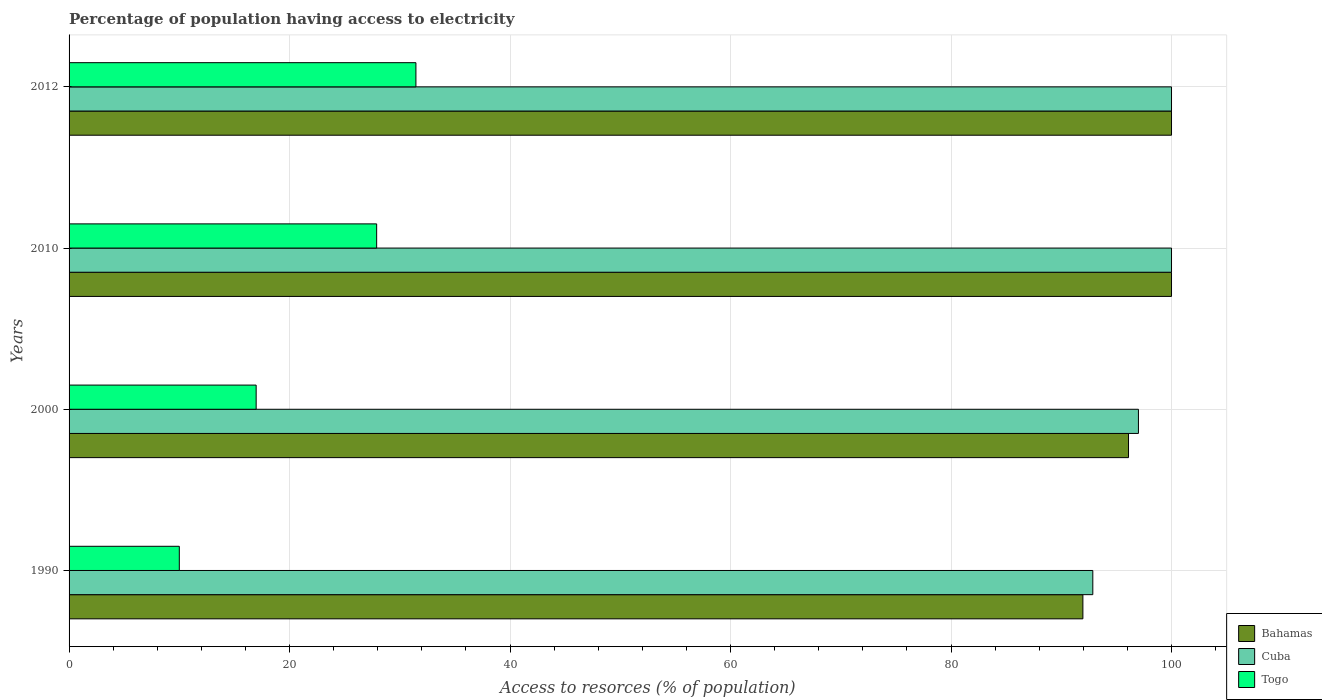How many different coloured bars are there?
Keep it short and to the point. 3. How many groups of bars are there?
Keep it short and to the point. 4. Are the number of bars per tick equal to the number of legend labels?
Your response must be concise. Yes. How many bars are there on the 2nd tick from the top?
Make the answer very short. 3. How many bars are there on the 2nd tick from the bottom?
Give a very brief answer. 3. In how many cases, is the number of bars for a given year not equal to the number of legend labels?
Provide a succinct answer. 0. What is the percentage of population having access to electricity in Bahamas in 2000?
Offer a terse response. 96.1. What is the total percentage of population having access to electricity in Cuba in the graph?
Provide a short and direct response. 389.86. What is the difference between the percentage of population having access to electricity in Bahamas in 1990 and the percentage of population having access to electricity in Togo in 2000?
Provide a succinct answer. 74.99. What is the average percentage of population having access to electricity in Togo per year?
Keep it short and to the point. 21.58. In the year 2010, what is the difference between the percentage of population having access to electricity in Togo and percentage of population having access to electricity in Bahamas?
Your answer should be very brief. -72.1. In how many years, is the percentage of population having access to electricity in Bahamas greater than 48 %?
Your answer should be very brief. 4. What is the ratio of the percentage of population having access to electricity in Bahamas in 1990 to that in 2010?
Provide a short and direct response. 0.92. Is the percentage of population having access to electricity in Bahamas in 2010 less than that in 2012?
Ensure brevity in your answer.  No. What is the difference between the highest and the lowest percentage of population having access to electricity in Cuba?
Offer a terse response. 7.14. Is the sum of the percentage of population having access to electricity in Togo in 2000 and 2012 greater than the maximum percentage of population having access to electricity in Cuba across all years?
Ensure brevity in your answer.  No. What does the 2nd bar from the top in 2010 represents?
Offer a very short reply. Cuba. What does the 2nd bar from the bottom in 2010 represents?
Offer a terse response. Cuba. Is it the case that in every year, the sum of the percentage of population having access to electricity in Togo and percentage of population having access to electricity in Cuba is greater than the percentage of population having access to electricity in Bahamas?
Ensure brevity in your answer.  Yes. What is the difference between two consecutive major ticks on the X-axis?
Your response must be concise. 20. Are the values on the major ticks of X-axis written in scientific E-notation?
Provide a succinct answer. No. Does the graph contain any zero values?
Offer a very short reply. No. Does the graph contain grids?
Offer a very short reply. Yes. Where does the legend appear in the graph?
Offer a terse response. Bottom right. How many legend labels are there?
Offer a very short reply. 3. What is the title of the graph?
Provide a short and direct response. Percentage of population having access to electricity. Does "Romania" appear as one of the legend labels in the graph?
Your response must be concise. No. What is the label or title of the X-axis?
Ensure brevity in your answer.  Access to resorces (% of population). What is the Access to resorces (% of population) in Bahamas in 1990?
Offer a very short reply. 91.96. What is the Access to resorces (% of population) of Cuba in 1990?
Offer a terse response. 92.86. What is the Access to resorces (% of population) in Bahamas in 2000?
Keep it short and to the point. 96.1. What is the Access to resorces (% of population) of Cuba in 2000?
Offer a terse response. 97. What is the Access to resorces (% of population) of Togo in 2000?
Offer a very short reply. 16.97. What is the Access to resorces (% of population) of Cuba in 2010?
Ensure brevity in your answer.  100. What is the Access to resorces (% of population) in Togo in 2010?
Offer a terse response. 27.9. What is the Access to resorces (% of population) of Bahamas in 2012?
Give a very brief answer. 100. What is the Access to resorces (% of population) of Togo in 2012?
Make the answer very short. 31.46. Across all years, what is the maximum Access to resorces (% of population) of Cuba?
Keep it short and to the point. 100. Across all years, what is the maximum Access to resorces (% of population) of Togo?
Make the answer very short. 31.46. Across all years, what is the minimum Access to resorces (% of population) of Bahamas?
Your answer should be very brief. 91.96. Across all years, what is the minimum Access to resorces (% of population) in Cuba?
Offer a terse response. 92.86. Across all years, what is the minimum Access to resorces (% of population) of Togo?
Make the answer very short. 10. What is the total Access to resorces (% of population) in Bahamas in the graph?
Your answer should be very brief. 388.06. What is the total Access to resorces (% of population) of Cuba in the graph?
Your answer should be very brief. 389.86. What is the total Access to resorces (% of population) in Togo in the graph?
Your answer should be compact. 86.33. What is the difference between the Access to resorces (% of population) in Bahamas in 1990 and that in 2000?
Your answer should be compact. -4.14. What is the difference between the Access to resorces (% of population) in Cuba in 1990 and that in 2000?
Keep it short and to the point. -4.14. What is the difference between the Access to resorces (% of population) of Togo in 1990 and that in 2000?
Provide a short and direct response. -6.97. What is the difference between the Access to resorces (% of population) of Bahamas in 1990 and that in 2010?
Keep it short and to the point. -8.04. What is the difference between the Access to resorces (% of population) in Cuba in 1990 and that in 2010?
Make the answer very short. -7.14. What is the difference between the Access to resorces (% of population) of Togo in 1990 and that in 2010?
Your answer should be compact. -17.9. What is the difference between the Access to resorces (% of population) of Bahamas in 1990 and that in 2012?
Give a very brief answer. -8.04. What is the difference between the Access to resorces (% of population) in Cuba in 1990 and that in 2012?
Give a very brief answer. -7.14. What is the difference between the Access to resorces (% of population) in Togo in 1990 and that in 2012?
Make the answer very short. -21.46. What is the difference between the Access to resorces (% of population) in Bahamas in 2000 and that in 2010?
Your answer should be very brief. -3.9. What is the difference between the Access to resorces (% of population) in Cuba in 2000 and that in 2010?
Offer a very short reply. -3. What is the difference between the Access to resorces (% of population) of Togo in 2000 and that in 2010?
Your answer should be compact. -10.93. What is the difference between the Access to resorces (% of population) of Cuba in 2000 and that in 2012?
Ensure brevity in your answer.  -3. What is the difference between the Access to resorces (% of population) of Togo in 2000 and that in 2012?
Your answer should be compact. -14.49. What is the difference between the Access to resorces (% of population) in Togo in 2010 and that in 2012?
Provide a succinct answer. -3.56. What is the difference between the Access to resorces (% of population) in Bahamas in 1990 and the Access to resorces (% of population) in Cuba in 2000?
Ensure brevity in your answer.  -5.04. What is the difference between the Access to resorces (% of population) of Bahamas in 1990 and the Access to resorces (% of population) of Togo in 2000?
Your response must be concise. 74.99. What is the difference between the Access to resorces (% of population) in Cuba in 1990 and the Access to resorces (% of population) in Togo in 2000?
Make the answer very short. 75.89. What is the difference between the Access to resorces (% of population) of Bahamas in 1990 and the Access to resorces (% of population) of Cuba in 2010?
Make the answer very short. -8.04. What is the difference between the Access to resorces (% of population) in Bahamas in 1990 and the Access to resorces (% of population) in Togo in 2010?
Provide a succinct answer. 64.06. What is the difference between the Access to resorces (% of population) of Cuba in 1990 and the Access to resorces (% of population) of Togo in 2010?
Provide a short and direct response. 64.96. What is the difference between the Access to resorces (% of population) of Bahamas in 1990 and the Access to resorces (% of population) of Cuba in 2012?
Give a very brief answer. -8.04. What is the difference between the Access to resorces (% of population) of Bahamas in 1990 and the Access to resorces (% of population) of Togo in 2012?
Ensure brevity in your answer.  60.5. What is the difference between the Access to resorces (% of population) of Cuba in 1990 and the Access to resorces (% of population) of Togo in 2012?
Your answer should be very brief. 61.4. What is the difference between the Access to resorces (% of population) in Bahamas in 2000 and the Access to resorces (% of population) in Togo in 2010?
Keep it short and to the point. 68.2. What is the difference between the Access to resorces (% of population) in Cuba in 2000 and the Access to resorces (% of population) in Togo in 2010?
Make the answer very short. 69.1. What is the difference between the Access to resorces (% of population) in Bahamas in 2000 and the Access to resorces (% of population) in Cuba in 2012?
Offer a terse response. -3.9. What is the difference between the Access to resorces (% of population) of Bahamas in 2000 and the Access to resorces (% of population) of Togo in 2012?
Your answer should be very brief. 64.64. What is the difference between the Access to resorces (% of population) in Cuba in 2000 and the Access to resorces (% of population) in Togo in 2012?
Give a very brief answer. 65.54. What is the difference between the Access to resorces (% of population) of Bahamas in 2010 and the Access to resorces (% of population) of Cuba in 2012?
Your answer should be compact. 0. What is the difference between the Access to resorces (% of population) of Bahamas in 2010 and the Access to resorces (% of population) of Togo in 2012?
Your answer should be very brief. 68.54. What is the difference between the Access to resorces (% of population) in Cuba in 2010 and the Access to resorces (% of population) in Togo in 2012?
Provide a short and direct response. 68.54. What is the average Access to resorces (% of population) in Bahamas per year?
Ensure brevity in your answer.  97.02. What is the average Access to resorces (% of population) of Cuba per year?
Offer a very short reply. 97.47. What is the average Access to resorces (% of population) of Togo per year?
Provide a short and direct response. 21.58. In the year 1990, what is the difference between the Access to resorces (% of population) in Bahamas and Access to resorces (% of population) in Cuba?
Give a very brief answer. -0.9. In the year 1990, what is the difference between the Access to resorces (% of population) in Bahamas and Access to resorces (% of population) in Togo?
Provide a succinct answer. 81.96. In the year 1990, what is the difference between the Access to resorces (% of population) in Cuba and Access to resorces (% of population) in Togo?
Your response must be concise. 82.86. In the year 2000, what is the difference between the Access to resorces (% of population) in Bahamas and Access to resorces (% of population) in Cuba?
Keep it short and to the point. -0.9. In the year 2000, what is the difference between the Access to resorces (% of population) in Bahamas and Access to resorces (% of population) in Togo?
Give a very brief answer. 79.13. In the year 2000, what is the difference between the Access to resorces (% of population) in Cuba and Access to resorces (% of population) in Togo?
Provide a succinct answer. 80.03. In the year 2010, what is the difference between the Access to resorces (% of population) of Bahamas and Access to resorces (% of population) of Togo?
Your answer should be compact. 72.1. In the year 2010, what is the difference between the Access to resorces (% of population) in Cuba and Access to resorces (% of population) in Togo?
Your answer should be very brief. 72.1. In the year 2012, what is the difference between the Access to resorces (% of population) of Bahamas and Access to resorces (% of population) of Cuba?
Keep it short and to the point. 0. In the year 2012, what is the difference between the Access to resorces (% of population) of Bahamas and Access to resorces (% of population) of Togo?
Your answer should be compact. 68.54. In the year 2012, what is the difference between the Access to resorces (% of population) of Cuba and Access to resorces (% of population) of Togo?
Offer a terse response. 68.54. What is the ratio of the Access to resorces (% of population) of Bahamas in 1990 to that in 2000?
Keep it short and to the point. 0.96. What is the ratio of the Access to resorces (% of population) of Cuba in 1990 to that in 2000?
Provide a succinct answer. 0.96. What is the ratio of the Access to resorces (% of population) in Togo in 1990 to that in 2000?
Ensure brevity in your answer.  0.59. What is the ratio of the Access to resorces (% of population) of Bahamas in 1990 to that in 2010?
Give a very brief answer. 0.92. What is the ratio of the Access to resorces (% of population) of Togo in 1990 to that in 2010?
Offer a terse response. 0.36. What is the ratio of the Access to resorces (% of population) in Bahamas in 1990 to that in 2012?
Your answer should be compact. 0.92. What is the ratio of the Access to resorces (% of population) of Togo in 1990 to that in 2012?
Ensure brevity in your answer.  0.32. What is the ratio of the Access to resorces (% of population) of Cuba in 2000 to that in 2010?
Provide a succinct answer. 0.97. What is the ratio of the Access to resorces (% of population) in Togo in 2000 to that in 2010?
Make the answer very short. 0.61. What is the ratio of the Access to resorces (% of population) in Bahamas in 2000 to that in 2012?
Make the answer very short. 0.96. What is the ratio of the Access to resorces (% of population) of Cuba in 2000 to that in 2012?
Your response must be concise. 0.97. What is the ratio of the Access to resorces (% of population) of Togo in 2000 to that in 2012?
Keep it short and to the point. 0.54. What is the ratio of the Access to resorces (% of population) in Cuba in 2010 to that in 2012?
Give a very brief answer. 1. What is the ratio of the Access to resorces (% of population) in Togo in 2010 to that in 2012?
Your answer should be very brief. 0.89. What is the difference between the highest and the second highest Access to resorces (% of population) of Togo?
Offer a very short reply. 3.56. What is the difference between the highest and the lowest Access to resorces (% of population) of Bahamas?
Your answer should be very brief. 8.04. What is the difference between the highest and the lowest Access to resorces (% of population) of Cuba?
Provide a succinct answer. 7.14. What is the difference between the highest and the lowest Access to resorces (% of population) in Togo?
Provide a short and direct response. 21.46. 